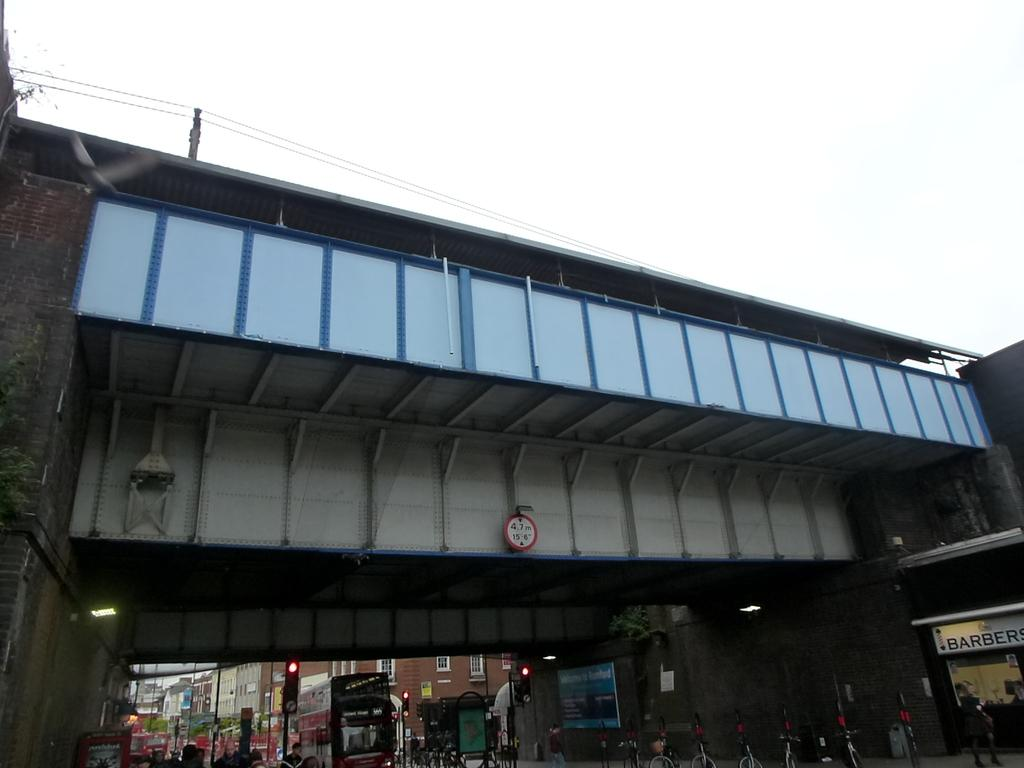What is the main structure in the middle of the picture? There is a bridge in the middle of the picture. What is located at the bottom of the picture? There is a traffic light at the bottom of the picture. What can be seen in the background of the picture? There are buildings and the sky visible in the background of the picture. What type of alley can be seen behind the bedroom in the image? There is no alley or bedroom present in the image; it features a bridge, traffic light, buildings, and the sky. 